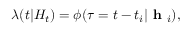Convert formula to latex. <formula><loc_0><loc_0><loc_500><loc_500>\lambda ( t | H _ { t } ) = \phi ( \tau = t - t _ { i } | h _ { i } ) ,</formula> 